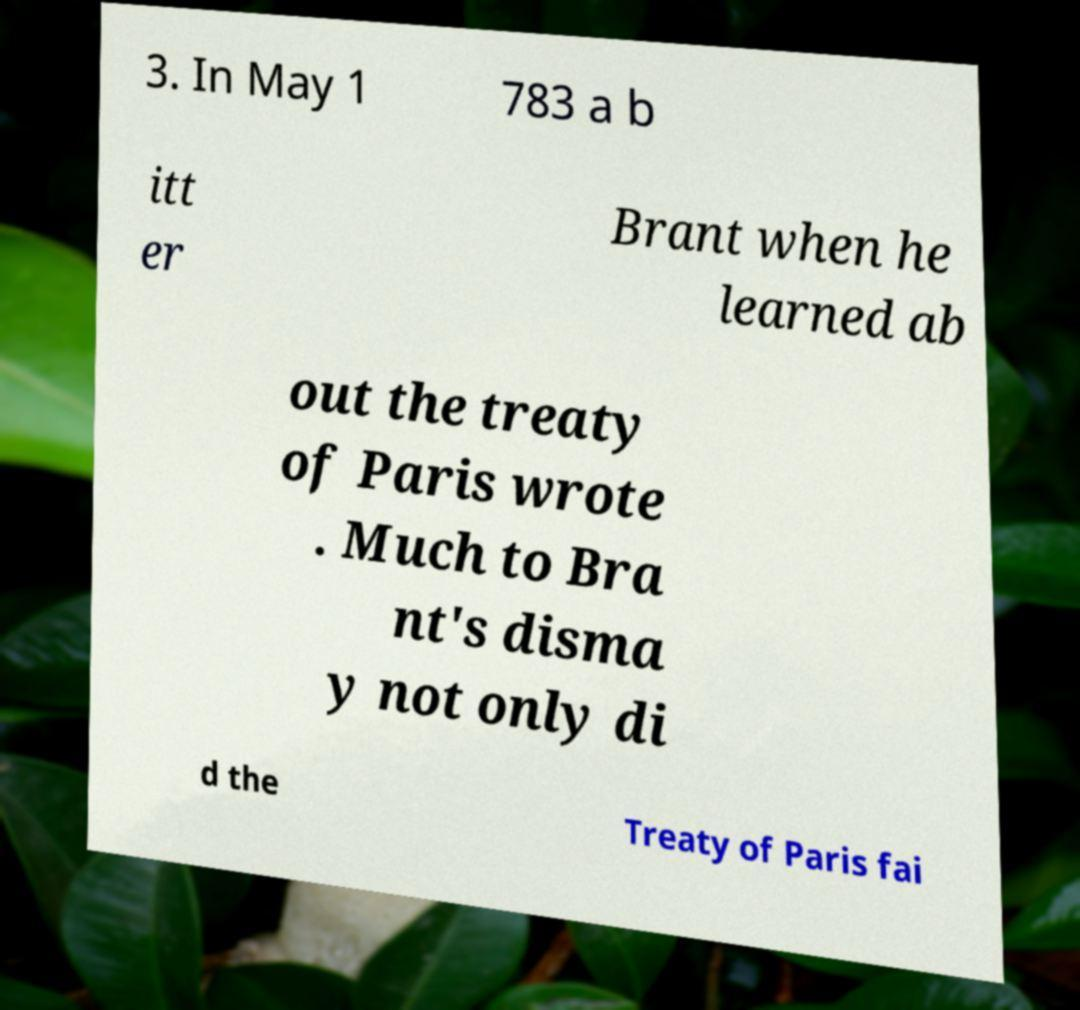For documentation purposes, I need the text within this image transcribed. Could you provide that? 3. In May 1 783 a b itt er Brant when he learned ab out the treaty of Paris wrote . Much to Bra nt's disma y not only di d the Treaty of Paris fai 